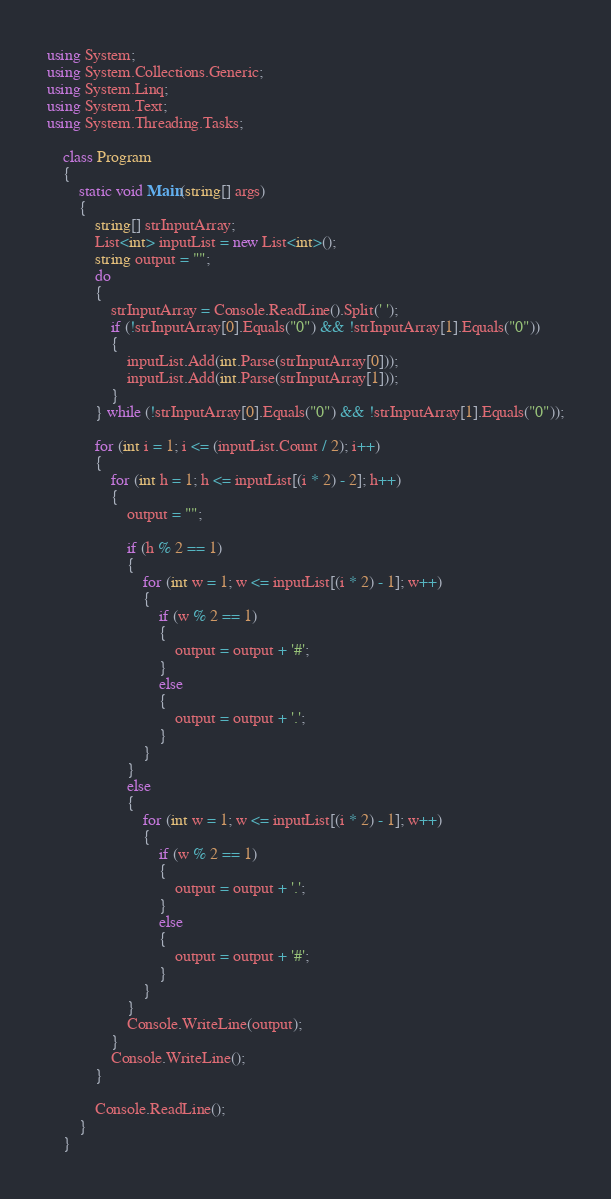<code> <loc_0><loc_0><loc_500><loc_500><_C#_>using System;
using System.Collections.Generic;
using System.Linq;
using System.Text;
using System.Threading.Tasks;

    class Program
    {
        static void Main(string[] args)
        {
            string[] strInputArray;
            List<int> inputList = new List<int>();
            string output = "";
            do
            {
                strInputArray = Console.ReadLine().Split(' ');
                if (!strInputArray[0].Equals("0") && !strInputArray[1].Equals("0"))
                {
                    inputList.Add(int.Parse(strInputArray[0]));
                    inputList.Add(int.Parse(strInputArray[1]));
                }
            } while (!strInputArray[0].Equals("0") && !strInputArray[1].Equals("0"));

            for (int i = 1; i <= (inputList.Count / 2); i++)
            {
                for (int h = 1; h <= inputList[(i * 2) - 2]; h++)
                {
                    output = "";

                    if (h % 2 == 1)
                    {
                        for (int w = 1; w <= inputList[(i * 2) - 1]; w++)
                        {
                            if (w % 2 == 1)
                            {
                                output = output + '#';
                            }
                            else
                            {
                                output = output + '.';
                            }
                        }
                    }
                    else
                    {
                        for (int w = 1; w <= inputList[(i * 2) - 1]; w++)
                        {
                            if (w % 2 == 1)
                            {
                                output = output + '.';
                            }
                            else
                            {
                                output = output + '#';
                            }
                        }
                    }
                    Console.WriteLine(output);
                }
                Console.WriteLine();
            }

            Console.ReadLine();
        }
    }
</code> 